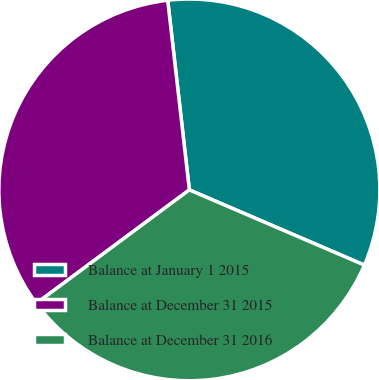Convert chart. <chart><loc_0><loc_0><loc_500><loc_500><pie_chart><fcel>Balance at January 1 2015<fcel>Balance at December 31 2015<fcel>Balance at December 31 2016<nl><fcel>33.26%<fcel>33.33%<fcel>33.41%<nl></chart> 